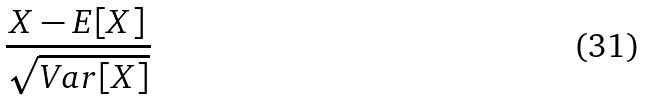Convert formula to latex. <formula><loc_0><loc_0><loc_500><loc_500>\frac { X - E [ X ] } { \sqrt { V a r [ X ] } }</formula> 